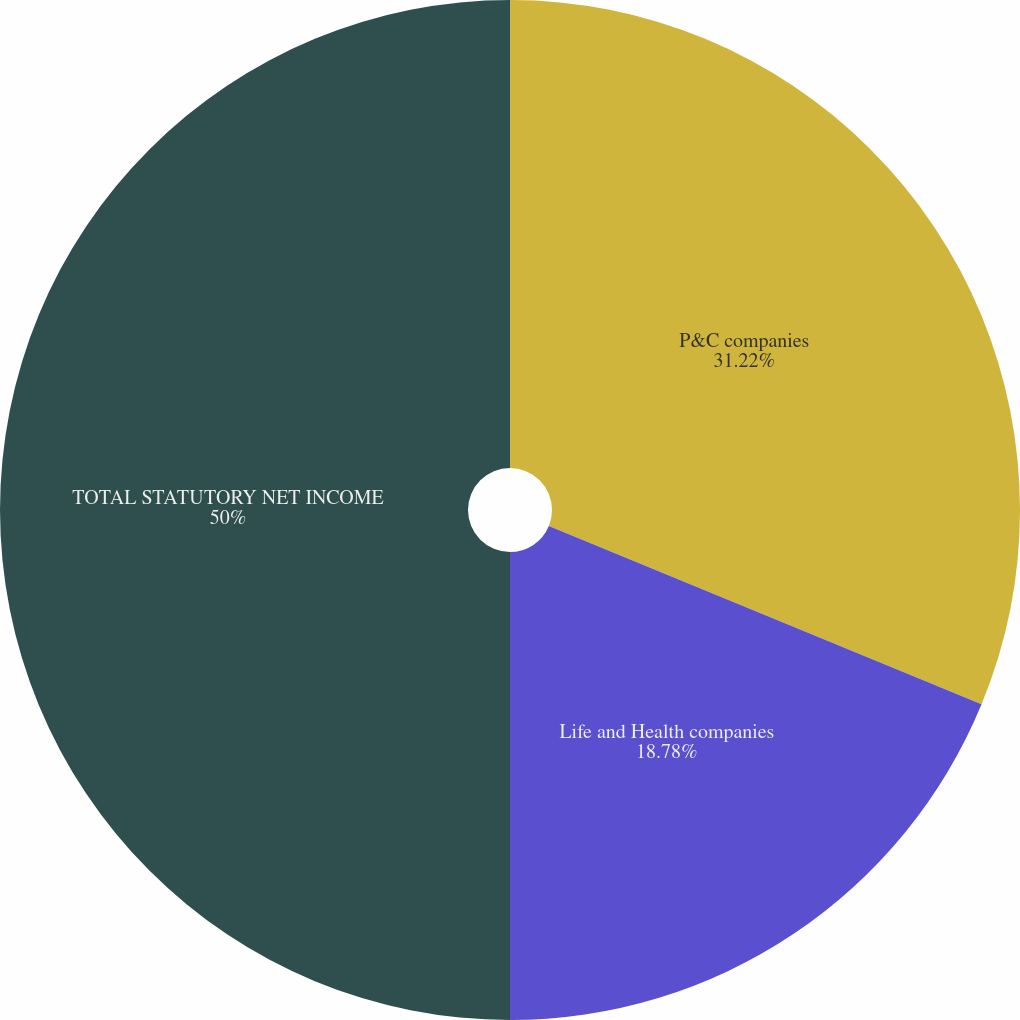Convert chart. <chart><loc_0><loc_0><loc_500><loc_500><pie_chart><fcel>P&C companies<fcel>Life and Health companies<fcel>TOTAL STATUTORY NET INCOME<nl><fcel>31.22%<fcel>18.78%<fcel>50.0%<nl></chart> 